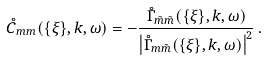Convert formula to latex. <formula><loc_0><loc_0><loc_500><loc_500>\mathring { C } _ { m m } ( \{ \xi \} , k , \omega ) = - \frac { \mathring { \Gamma } _ { \tilde { m } \tilde { m } } ( \{ \xi \} , k , \omega ) } { \left | \mathring { \Gamma } _ { m \tilde { m } } ( \{ \xi \} , k , \omega ) \right | ^ { 2 } } \, .</formula> 